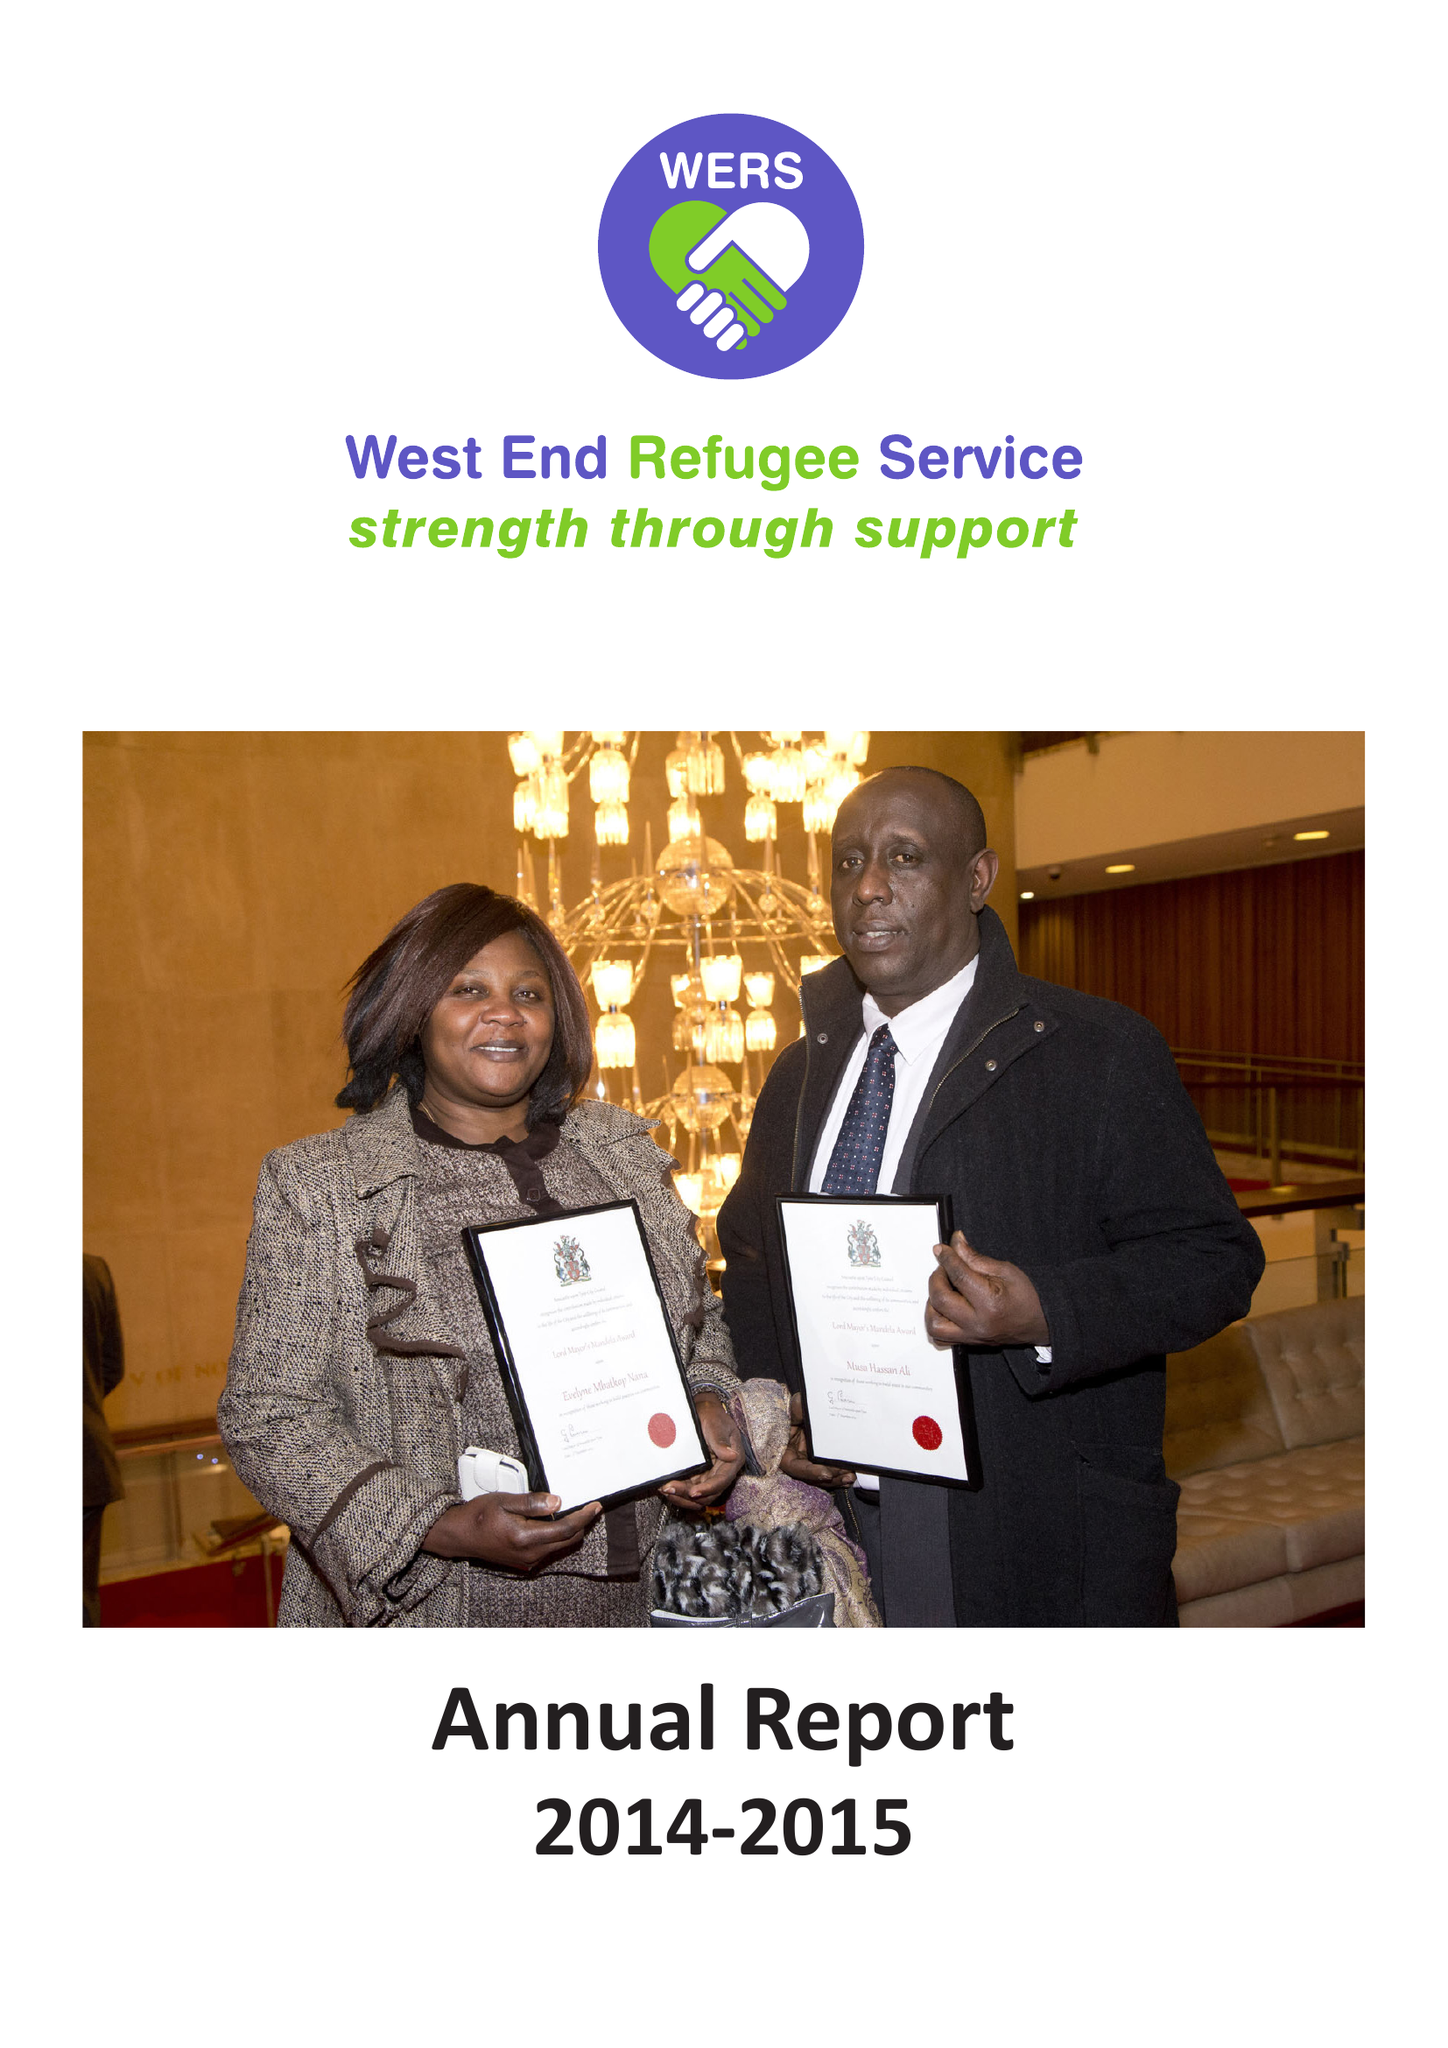What is the value for the report_date?
Answer the question using a single word or phrase. 2015-03-31 